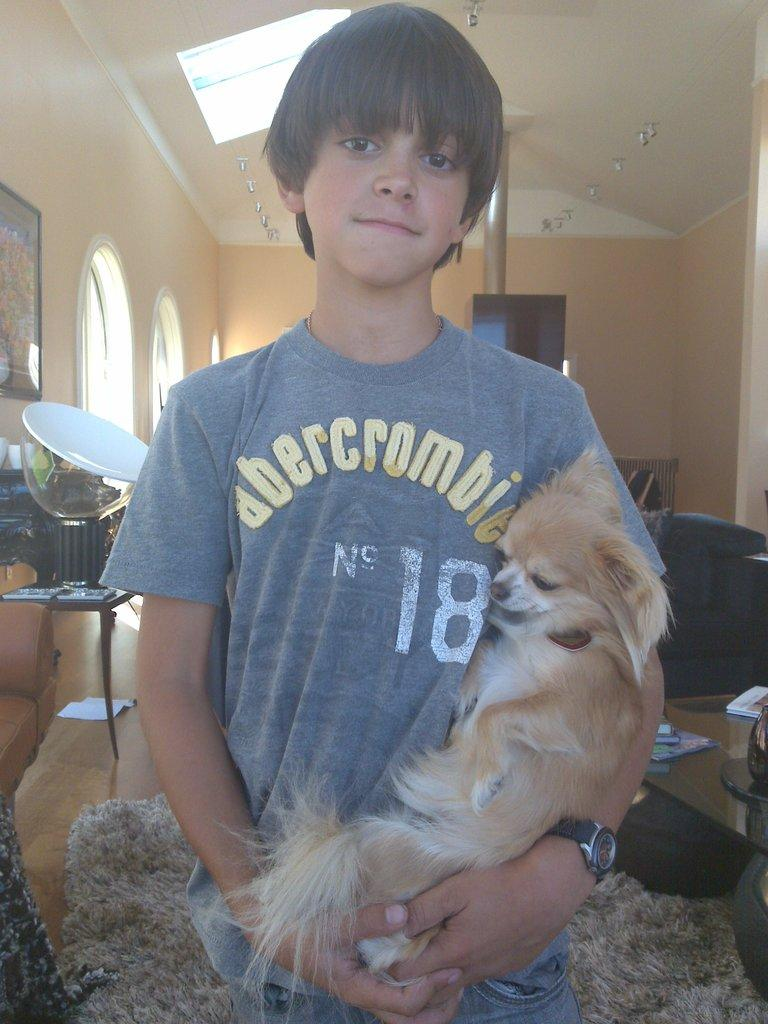What is the person in the image doing? The person is standing in the image and holding a dog. Can you describe the dog in the image? The provided facts do not give any information about the dog's appearance or breed. What can be seen in the background of the image? There are objects on a table and a frame attached to the wall in the background of the image. What type of protest is happening in the image? There is no protest present in the image; it features a person holding a dog and other background elements. How many cakes are visible on the table in the image? The provided facts do not mention any cakes in the image; they only mention objects on the table. 